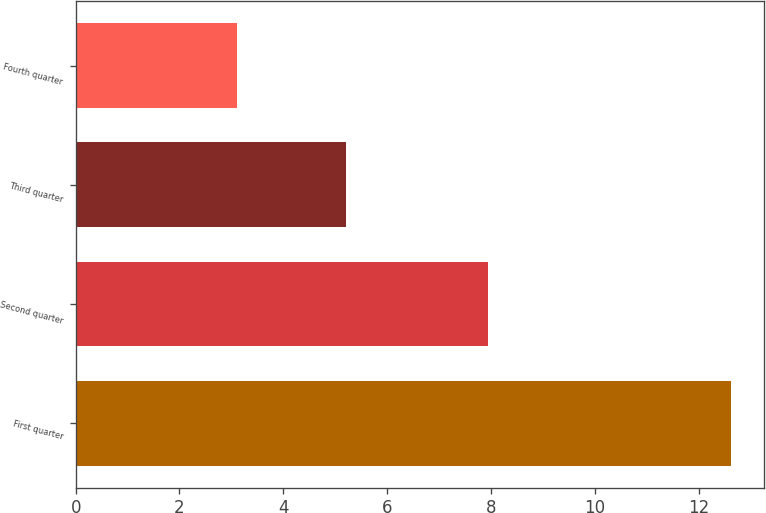Convert chart. <chart><loc_0><loc_0><loc_500><loc_500><bar_chart><fcel>First quarter<fcel>Second quarter<fcel>Third quarter<fcel>Fourth quarter<nl><fcel>12.63<fcel>7.95<fcel>5.2<fcel>3.1<nl></chart> 